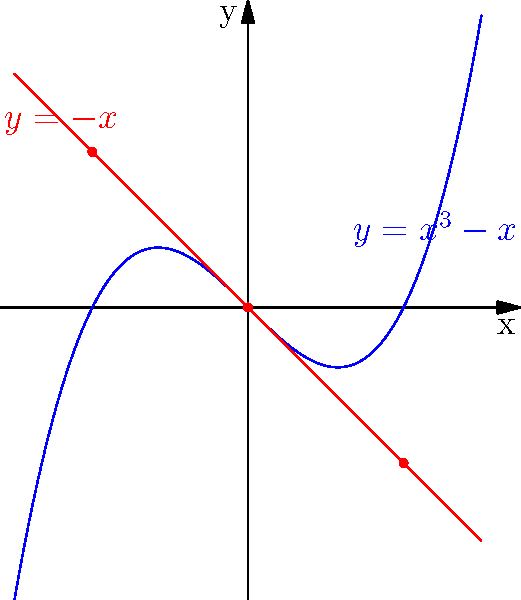Consider the vector field $\mathbf{F}(x,y) = (y+x^3-x, -x)$ on $\mathbb{R}^2$. Identify the type and stability of the singularity at the origin $(0,0)$. To classify the singularity at $(0,0)$, we follow these steps:

1) First, we need to find the Jacobian matrix of $\mathbf{F}$ at $(0,0)$:

   $J(0,0) = \begin{pmatrix}
   \frac{\partial F_1}{\partial x} & \frac{\partial F_1}{\partial y} \\
   \frac{\partial F_2}{\partial x} & \frac{\partial F_2}{\partial y}
   \end{pmatrix}_{(0,0)}
   = \begin{pmatrix}
   3x^2-1 & 1 \\
   -1 & 0
   \end{pmatrix}_{(0,0)}
   = \begin{pmatrix}
   -1 & 1 \\
   -1 & 0
   \end{pmatrix}$

2) Now, we calculate the eigenvalues of this matrix:

   $\det(J - \lambda I) = \begin{vmatrix}
   -1-\lambda & 1 \\
   -1 & -\lambda
   \end{vmatrix} = \lambda^2 + \lambda + 1 = 0$

3) Solving this quadratic equation:

   $\lambda = \frac{-1 \pm \sqrt{1-4}}{2} = \frac{-1 \pm i\sqrt{3}}{2}$

4) We have complex conjugate eigenvalues with non-zero real and imaginary parts.

5) The real part is negative $(-\frac{1}{2})$, indicating that trajectories spiral inward towards the origin.

6) The imaginary part ($\pm\frac{\sqrt{3}}{2}$) indicates rotation around the origin.

Therefore, the singularity at $(0,0)$ is a stable spiral point (also known as a stable focus).
Answer: Stable spiral point 